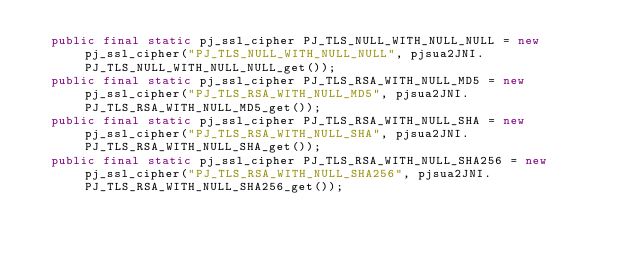Convert code to text. <code><loc_0><loc_0><loc_500><loc_500><_Java_>  public final static pj_ssl_cipher PJ_TLS_NULL_WITH_NULL_NULL = new pj_ssl_cipher("PJ_TLS_NULL_WITH_NULL_NULL", pjsua2JNI.PJ_TLS_NULL_WITH_NULL_NULL_get());
  public final static pj_ssl_cipher PJ_TLS_RSA_WITH_NULL_MD5 = new pj_ssl_cipher("PJ_TLS_RSA_WITH_NULL_MD5", pjsua2JNI.PJ_TLS_RSA_WITH_NULL_MD5_get());
  public final static pj_ssl_cipher PJ_TLS_RSA_WITH_NULL_SHA = new pj_ssl_cipher("PJ_TLS_RSA_WITH_NULL_SHA", pjsua2JNI.PJ_TLS_RSA_WITH_NULL_SHA_get());
  public final static pj_ssl_cipher PJ_TLS_RSA_WITH_NULL_SHA256 = new pj_ssl_cipher("PJ_TLS_RSA_WITH_NULL_SHA256", pjsua2JNI.PJ_TLS_RSA_WITH_NULL_SHA256_get());</code> 